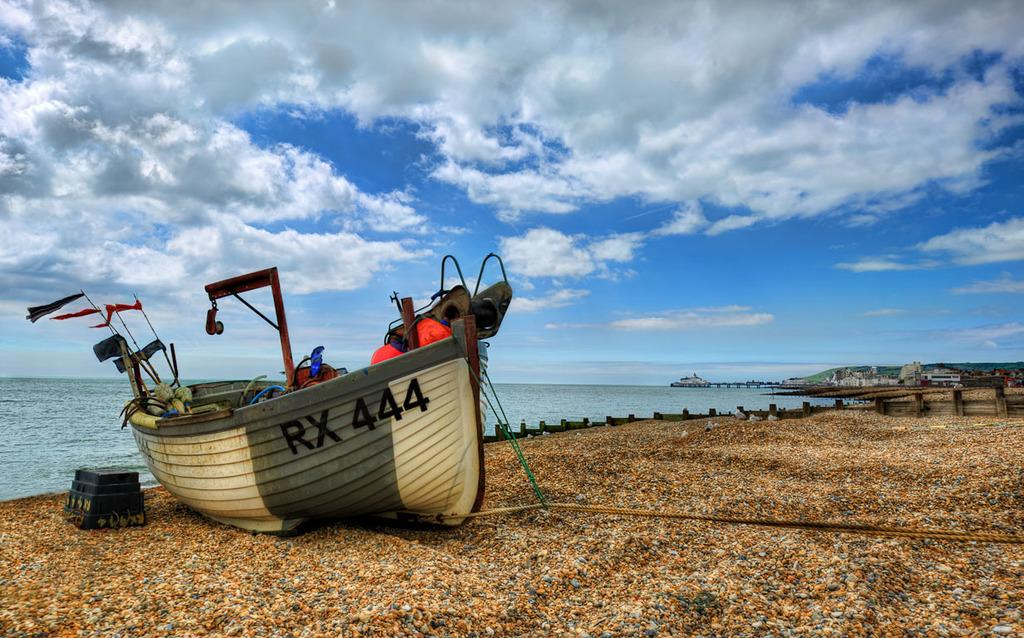<image>
Share a concise interpretation of the image provided. A canoe style boat on a pebble covered beach has RX 444 on the side. 